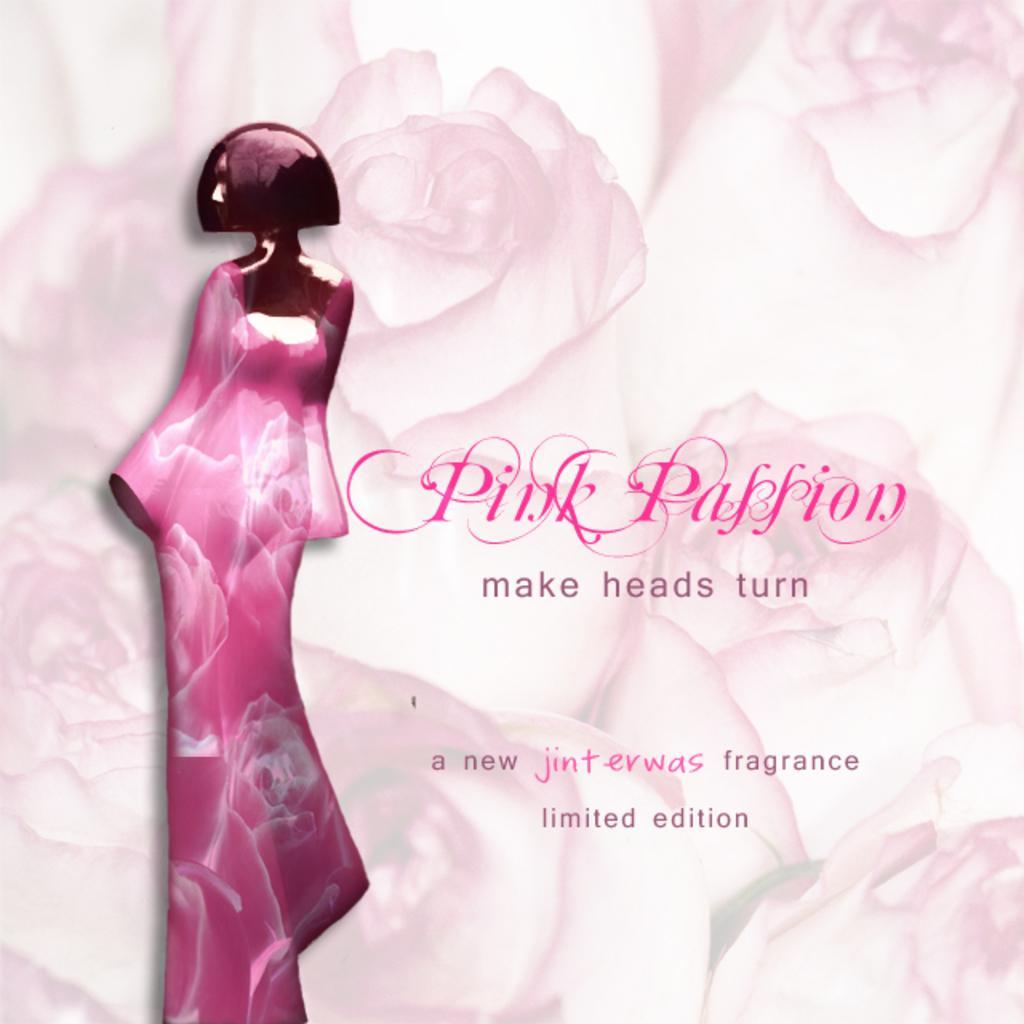Could you give a brief overview of what you see in this image? In the image there is a poster. On the poster there is a lady image and also there is something written on it. Behind them there are flowers in the background. 